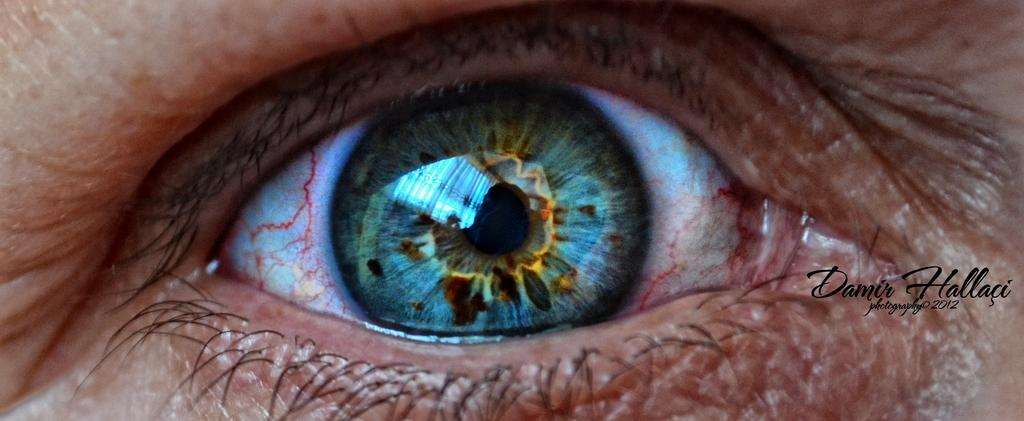What is the main subject of the image? The main subject of the image is the eye of a person. What is unique about the eye in the image? There is text on the eye in the image. What type of mountain can be seen in the background of the image? There is no mountain present in the image; it features the eye of a person with text on it. What type of stocking is the person wearing in the image? There is no stocking visible in the image, as it only shows the eye of a person with text on it. 